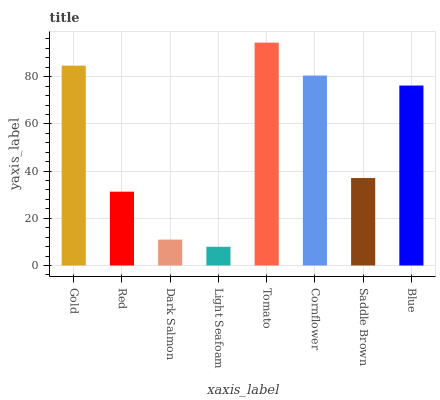Is Light Seafoam the minimum?
Answer yes or no. Yes. Is Tomato the maximum?
Answer yes or no. Yes. Is Red the minimum?
Answer yes or no. No. Is Red the maximum?
Answer yes or no. No. Is Gold greater than Red?
Answer yes or no. Yes. Is Red less than Gold?
Answer yes or no. Yes. Is Red greater than Gold?
Answer yes or no. No. Is Gold less than Red?
Answer yes or no. No. Is Blue the high median?
Answer yes or no. Yes. Is Saddle Brown the low median?
Answer yes or no. Yes. Is Dark Salmon the high median?
Answer yes or no. No. Is Light Seafoam the low median?
Answer yes or no. No. 